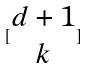Convert formula to latex. <formula><loc_0><loc_0><loc_500><loc_500>[ \begin{matrix} d + 1 \\ k \end{matrix} ]</formula> 